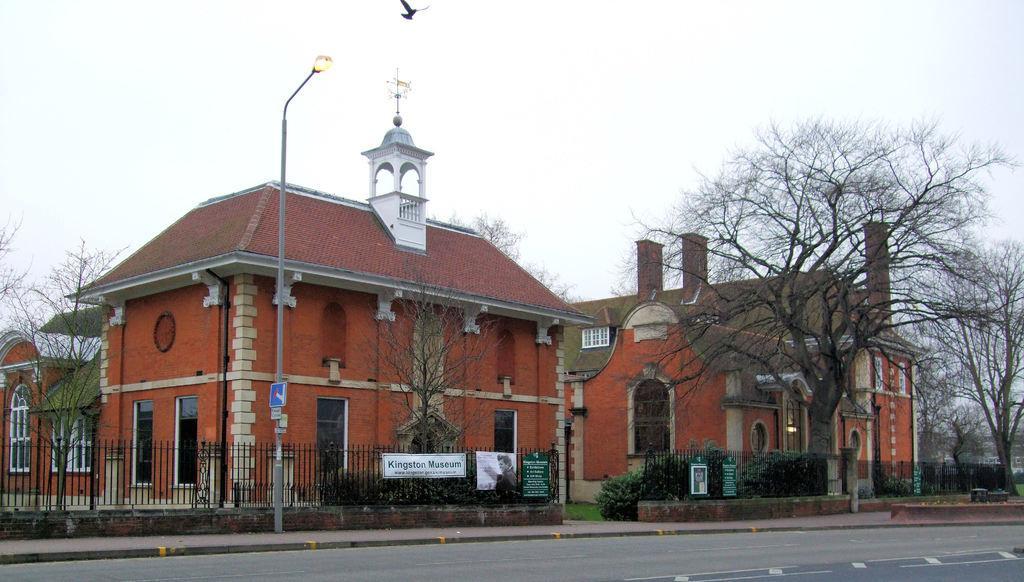Please provide a concise description of this image. In this picture in the background there is a fence and on the fence there is a board with some text written on it, there is a pole, there are buildings, trees and there is a bird flying in the sky and the sky is cloudy. 